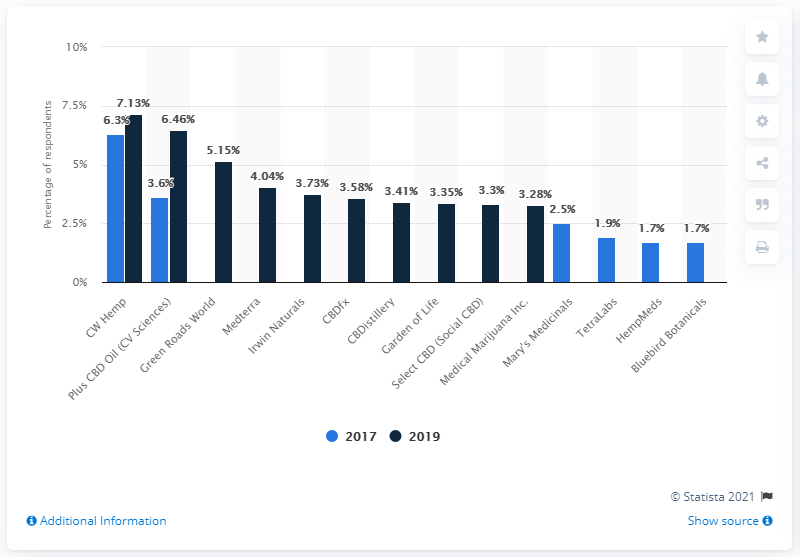Specify some key components in this picture. CW Hemp is the leading CBD brand based on user opinions. 